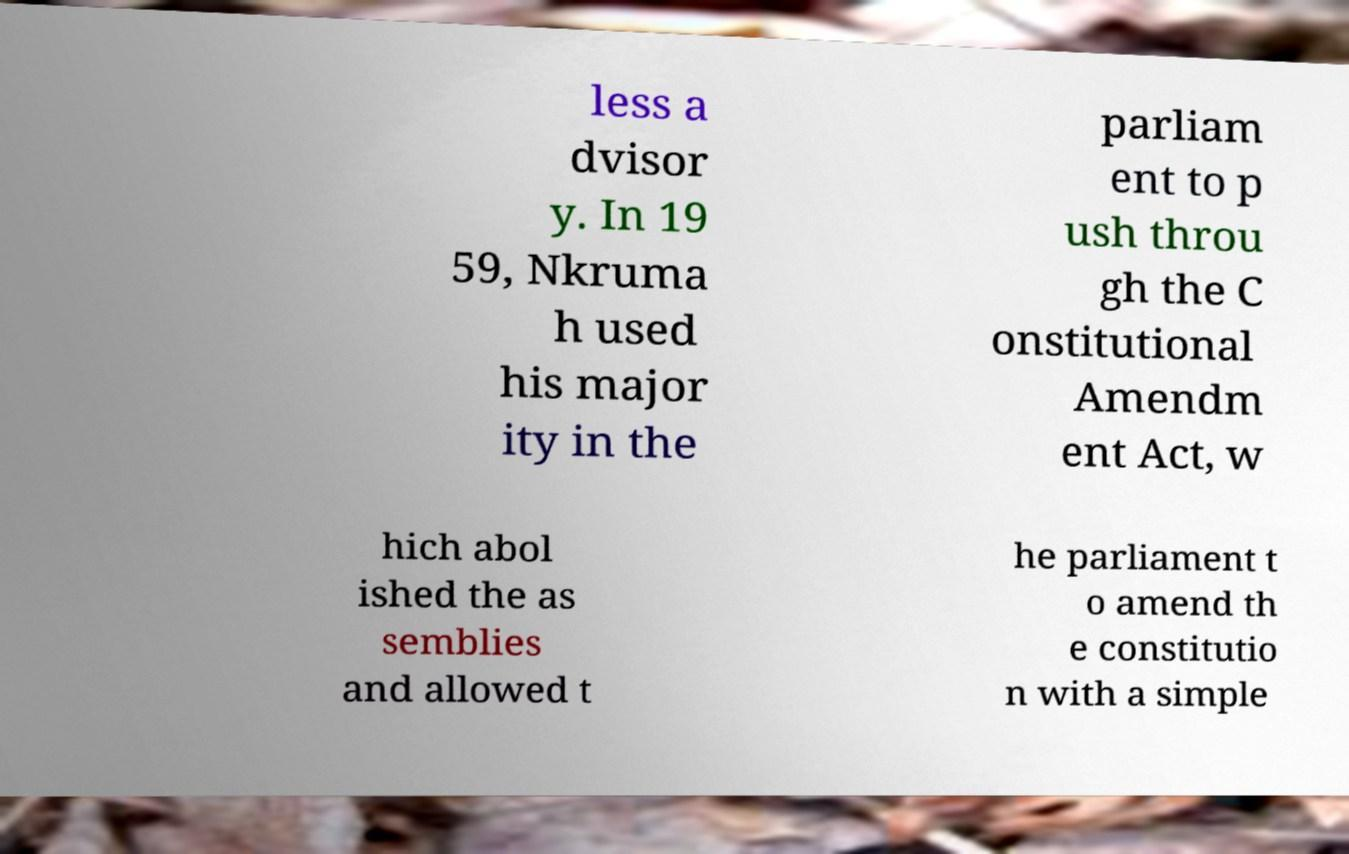Could you assist in decoding the text presented in this image and type it out clearly? less a dvisor y. In 19 59, Nkruma h used his major ity in the parliam ent to p ush throu gh the C onstitutional Amendm ent Act, w hich abol ished the as semblies and allowed t he parliament t o amend th e constitutio n with a simple 